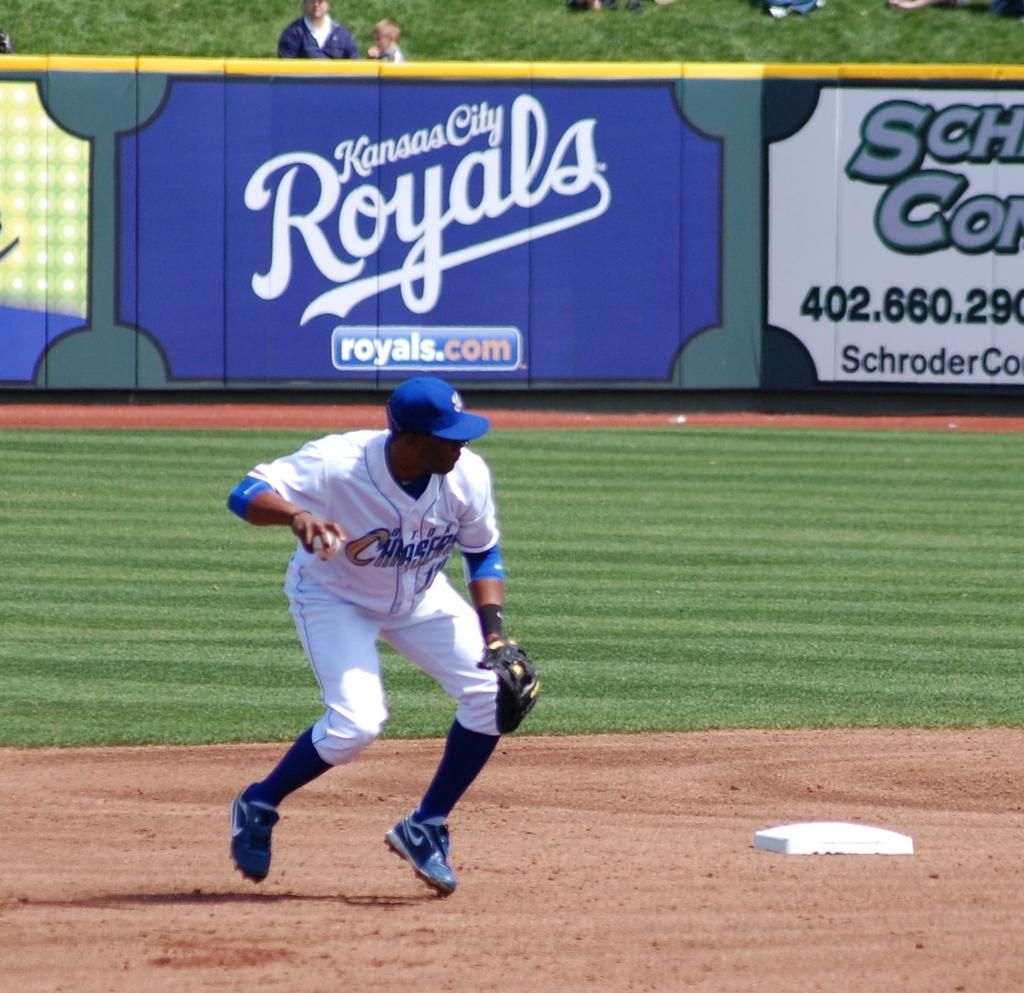<image>
Give a short and clear explanation of the subsequent image. A baseball player from Chargers playing near second base getting ready to throw the ball. 